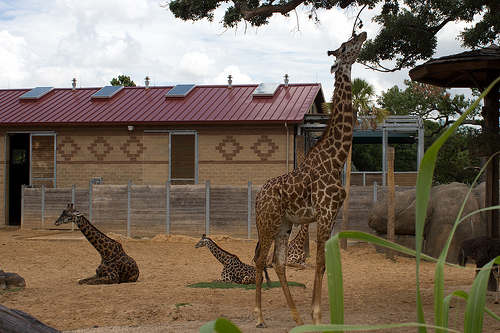Please provide a short description for this region: [0.76, 0.46, 0.8, 0.69]. The coordinates [0.76, 0.46, 0.8, 0.69] indicate a post on the ground. 